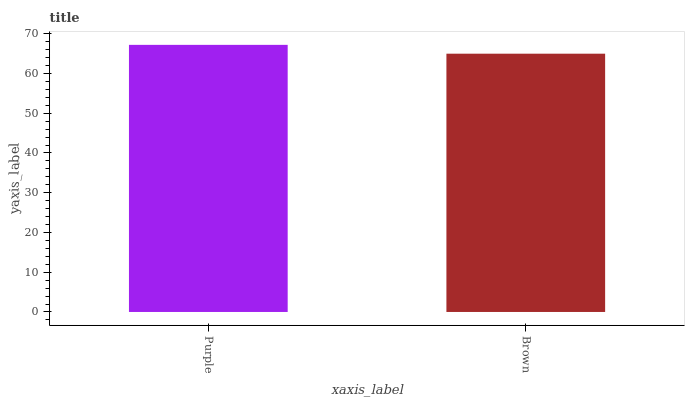Is Brown the minimum?
Answer yes or no. Yes. Is Purple the maximum?
Answer yes or no. Yes. Is Brown the maximum?
Answer yes or no. No. Is Purple greater than Brown?
Answer yes or no. Yes. Is Brown less than Purple?
Answer yes or no. Yes. Is Brown greater than Purple?
Answer yes or no. No. Is Purple less than Brown?
Answer yes or no. No. Is Purple the high median?
Answer yes or no. Yes. Is Brown the low median?
Answer yes or no. Yes. Is Brown the high median?
Answer yes or no. No. Is Purple the low median?
Answer yes or no. No. 